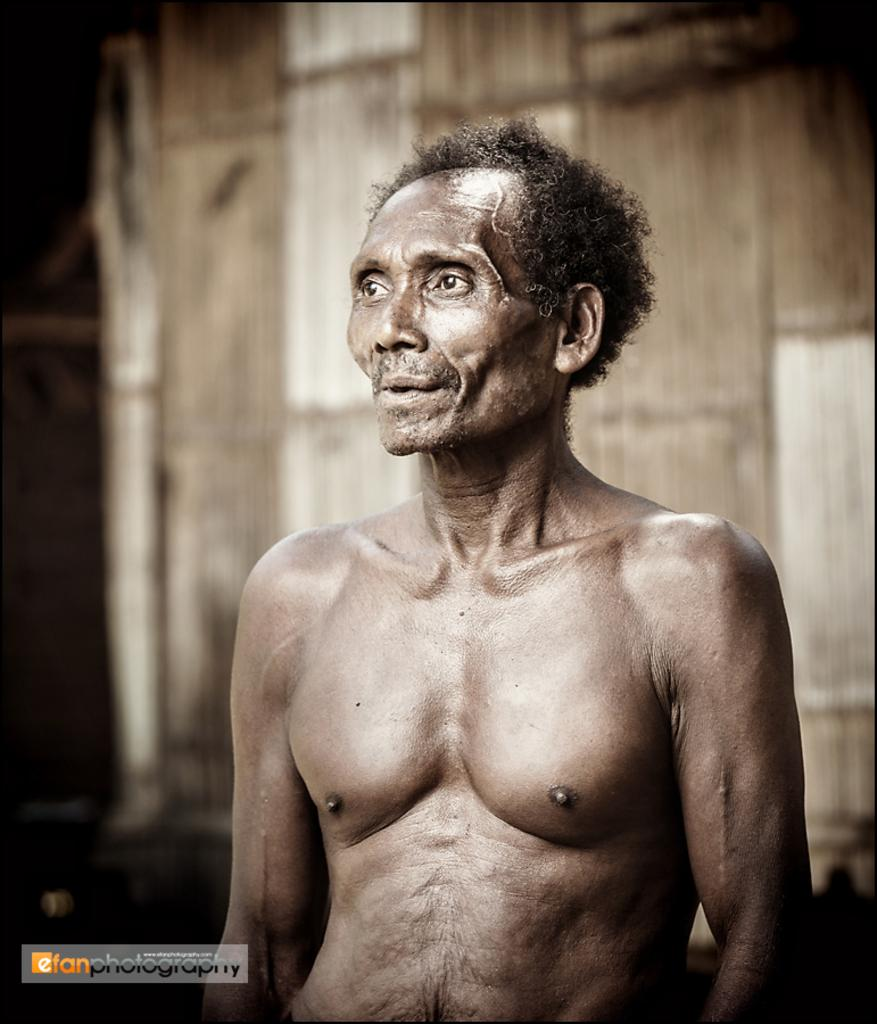Who is present in the image? There is a man in the image. Can you describe the background of the image? The background has a blurred view. Is there any additional information or marking on the image? Yes, there is a watermark on the left side bottom of the image. What grade did the man receive in his science class, as shown in the image? There is no information about the man's grades or science class in the image. 